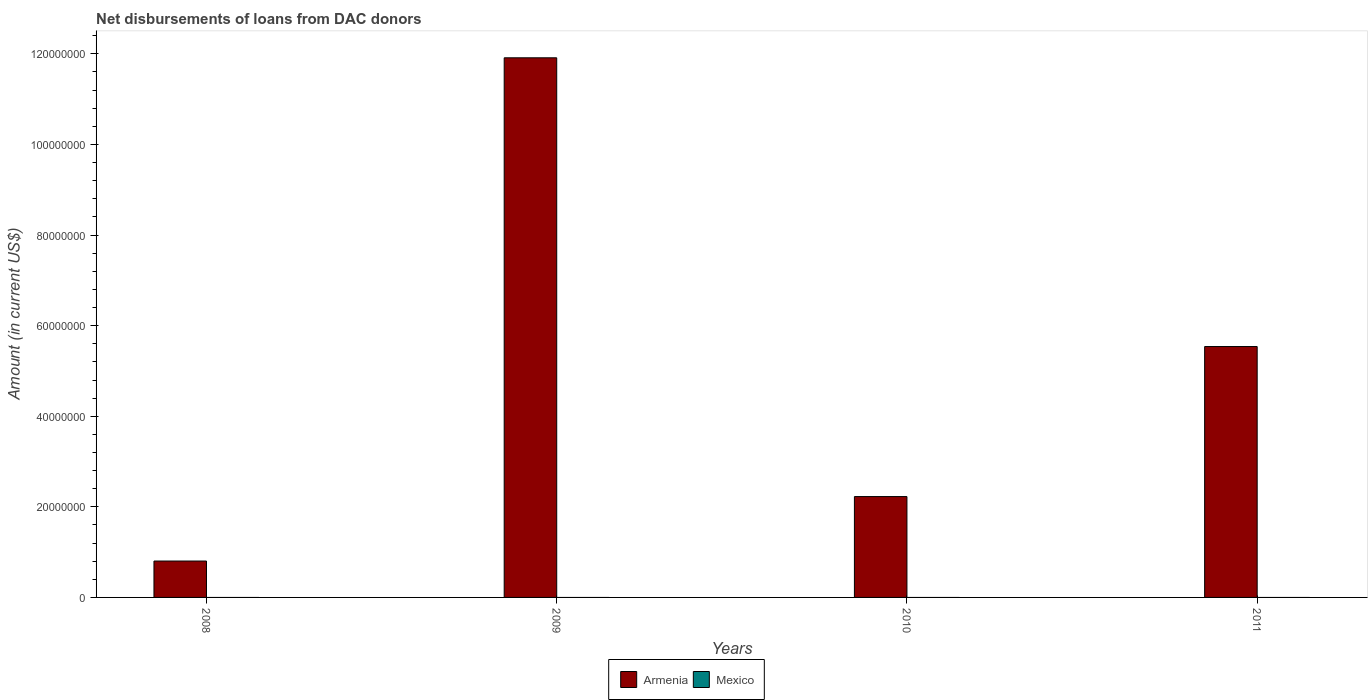How many different coloured bars are there?
Provide a short and direct response. 1. Are the number of bars per tick equal to the number of legend labels?
Keep it short and to the point. No. What is the label of the 3rd group of bars from the left?
Provide a succinct answer. 2010. In how many cases, is the number of bars for a given year not equal to the number of legend labels?
Provide a succinct answer. 4. Across all years, what is the maximum amount of loans disbursed in Armenia?
Give a very brief answer. 1.19e+08. In which year was the amount of loans disbursed in Armenia maximum?
Give a very brief answer. 2009. What is the difference between the amount of loans disbursed in Armenia in 2008 and that in 2011?
Make the answer very short. -4.74e+07. What is the difference between the amount of loans disbursed in Armenia in 2011 and the amount of loans disbursed in Mexico in 2010?
Your answer should be very brief. 5.54e+07. What is the average amount of loans disbursed in Armenia per year?
Keep it short and to the point. 5.12e+07. What is the ratio of the amount of loans disbursed in Armenia in 2008 to that in 2011?
Offer a very short reply. 0.15. Is the amount of loans disbursed in Armenia in 2009 less than that in 2010?
Ensure brevity in your answer.  No. What is the difference between the highest and the second highest amount of loans disbursed in Armenia?
Offer a very short reply. 6.37e+07. What is the difference between the highest and the lowest amount of loans disbursed in Armenia?
Your answer should be compact. 1.11e+08. In how many years, is the amount of loans disbursed in Mexico greater than the average amount of loans disbursed in Mexico taken over all years?
Your answer should be very brief. 0. Are all the bars in the graph horizontal?
Offer a terse response. No. What is the difference between two consecutive major ticks on the Y-axis?
Provide a short and direct response. 2.00e+07. Does the graph contain any zero values?
Your answer should be compact. Yes. Does the graph contain grids?
Provide a short and direct response. No. Where does the legend appear in the graph?
Provide a succinct answer. Bottom center. How many legend labels are there?
Provide a succinct answer. 2. What is the title of the graph?
Ensure brevity in your answer.  Net disbursements of loans from DAC donors. Does "Liechtenstein" appear as one of the legend labels in the graph?
Provide a short and direct response. No. What is the label or title of the X-axis?
Your answer should be compact. Years. What is the Amount (in current US$) in Armenia in 2008?
Offer a terse response. 8.03e+06. What is the Amount (in current US$) in Mexico in 2008?
Ensure brevity in your answer.  0. What is the Amount (in current US$) in Armenia in 2009?
Provide a succinct answer. 1.19e+08. What is the Amount (in current US$) of Armenia in 2010?
Your answer should be very brief. 2.23e+07. What is the Amount (in current US$) in Mexico in 2010?
Offer a very short reply. 0. What is the Amount (in current US$) of Armenia in 2011?
Your answer should be very brief. 5.54e+07. Across all years, what is the maximum Amount (in current US$) of Armenia?
Offer a terse response. 1.19e+08. Across all years, what is the minimum Amount (in current US$) in Armenia?
Provide a short and direct response. 8.03e+06. What is the total Amount (in current US$) of Armenia in the graph?
Provide a succinct answer. 2.05e+08. What is the difference between the Amount (in current US$) of Armenia in 2008 and that in 2009?
Provide a short and direct response. -1.11e+08. What is the difference between the Amount (in current US$) of Armenia in 2008 and that in 2010?
Keep it short and to the point. -1.42e+07. What is the difference between the Amount (in current US$) of Armenia in 2008 and that in 2011?
Offer a terse response. -4.74e+07. What is the difference between the Amount (in current US$) in Armenia in 2009 and that in 2010?
Your answer should be very brief. 9.69e+07. What is the difference between the Amount (in current US$) in Armenia in 2009 and that in 2011?
Your answer should be compact. 6.37e+07. What is the difference between the Amount (in current US$) of Armenia in 2010 and that in 2011?
Make the answer very short. -3.31e+07. What is the average Amount (in current US$) in Armenia per year?
Offer a terse response. 5.12e+07. What is the ratio of the Amount (in current US$) of Armenia in 2008 to that in 2009?
Offer a very short reply. 0.07. What is the ratio of the Amount (in current US$) in Armenia in 2008 to that in 2010?
Make the answer very short. 0.36. What is the ratio of the Amount (in current US$) in Armenia in 2008 to that in 2011?
Provide a succinct answer. 0.14. What is the ratio of the Amount (in current US$) of Armenia in 2009 to that in 2010?
Keep it short and to the point. 5.35. What is the ratio of the Amount (in current US$) of Armenia in 2009 to that in 2011?
Give a very brief answer. 2.15. What is the ratio of the Amount (in current US$) in Armenia in 2010 to that in 2011?
Keep it short and to the point. 0.4. What is the difference between the highest and the second highest Amount (in current US$) of Armenia?
Make the answer very short. 6.37e+07. What is the difference between the highest and the lowest Amount (in current US$) of Armenia?
Offer a very short reply. 1.11e+08. 